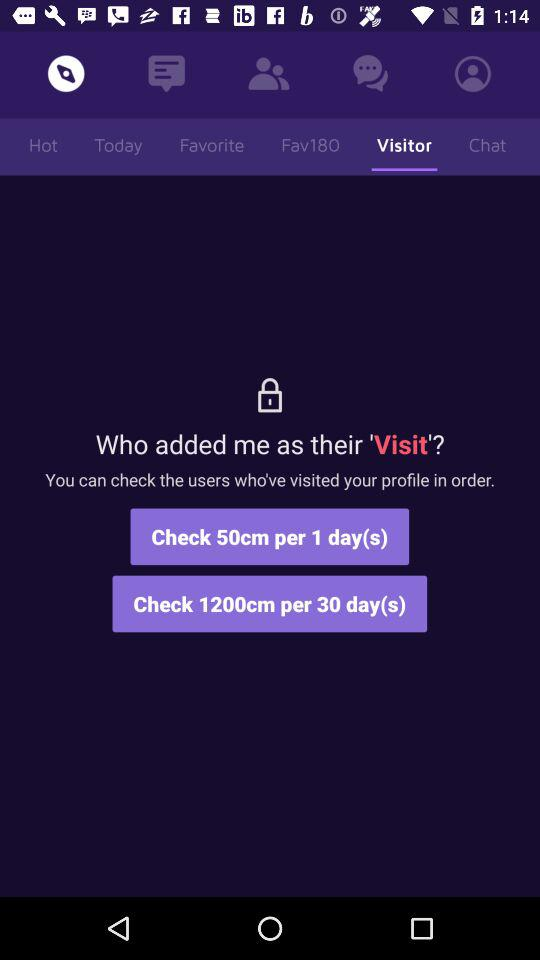Which tab am I now on? You are now on "Compass" and "Visitor" tabs. 